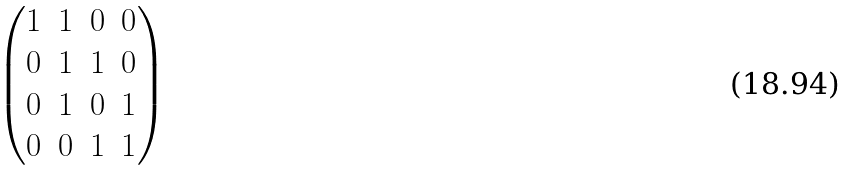Convert formula to latex. <formula><loc_0><loc_0><loc_500><loc_500>\begin{pmatrix} 1 & 1 & 0 & 0 \\ 0 & 1 & 1 & 0 \\ 0 & 1 & 0 & 1 \\ 0 & 0 & 1 & 1 \end{pmatrix}</formula> 